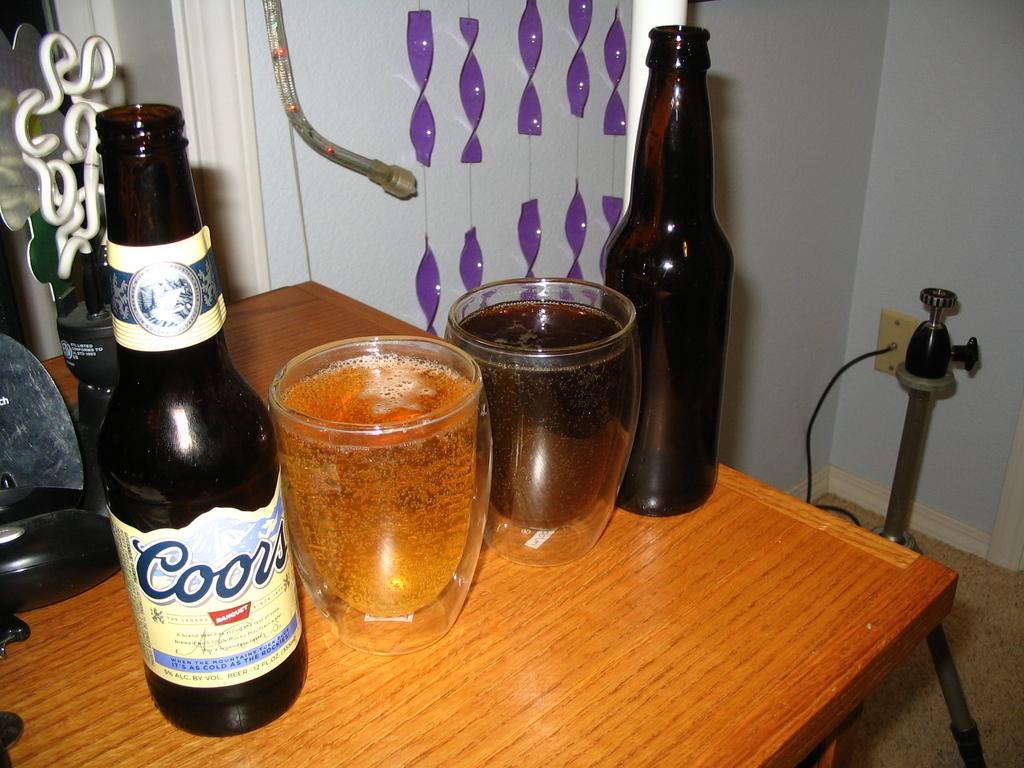Is there a bottle of coors?
Ensure brevity in your answer.  Yes. What is the word under the word coor's on the front of the bottle?
Provide a short and direct response. Banquet. 